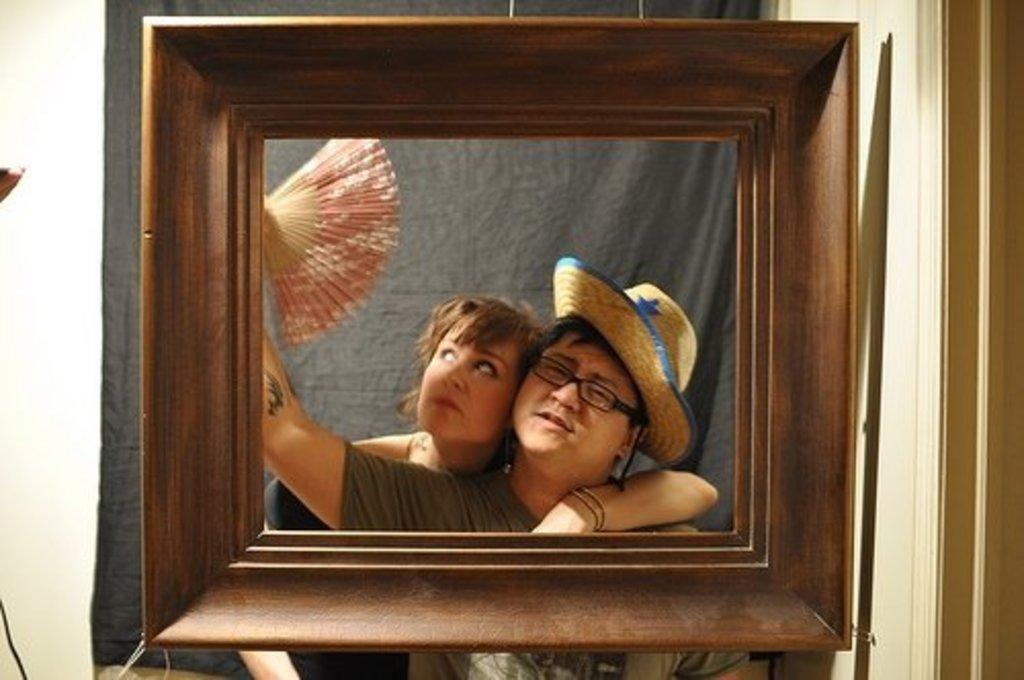What object is present in the image that might be used to display a photograph? There is a frame in the image. Who can be seen behind the frame? A man and a woman are visible behind the frame. What are the man and woman doing in the image? The man and woman are posing for a photograph. What type of jam is being spread on the brake in the image? There is no jam or brake present in the image; it features a frame with a man and a woman posing for a photograph. 